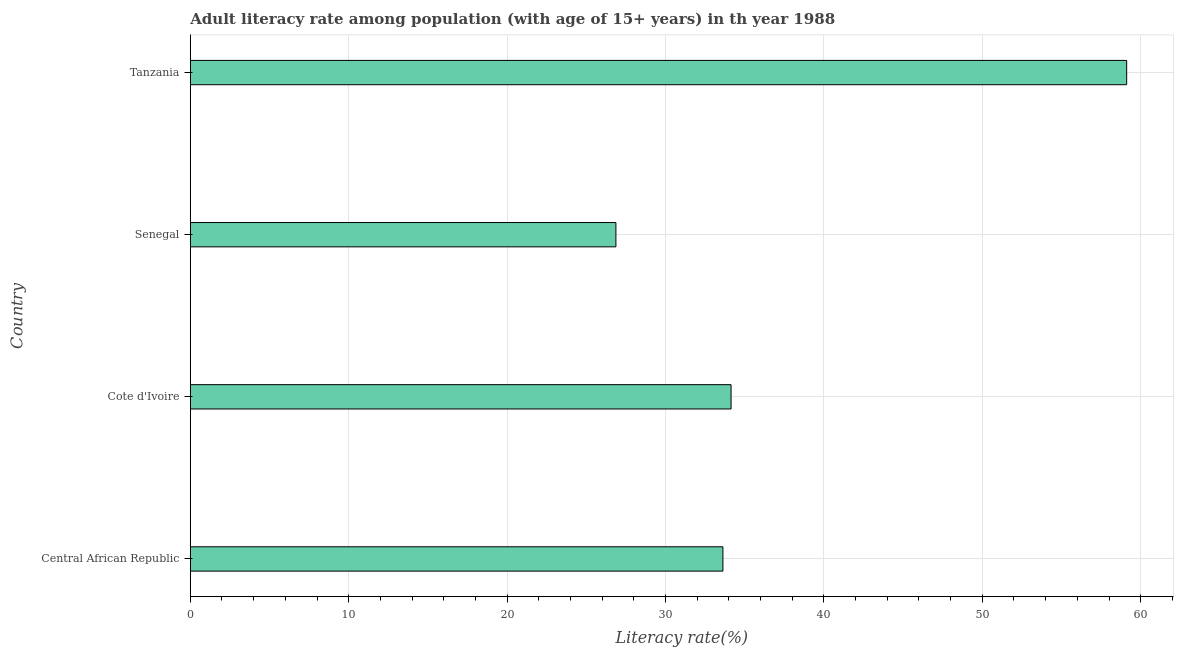Does the graph contain any zero values?
Make the answer very short. No. What is the title of the graph?
Provide a short and direct response. Adult literacy rate among population (with age of 15+ years) in th year 1988. What is the label or title of the X-axis?
Your answer should be very brief. Literacy rate(%). What is the label or title of the Y-axis?
Give a very brief answer. Country. What is the adult literacy rate in Senegal?
Provide a succinct answer. 26.87. Across all countries, what is the maximum adult literacy rate?
Provide a succinct answer. 59.11. Across all countries, what is the minimum adult literacy rate?
Provide a succinct answer. 26.87. In which country was the adult literacy rate maximum?
Your answer should be compact. Tanzania. In which country was the adult literacy rate minimum?
Provide a succinct answer. Senegal. What is the sum of the adult literacy rate?
Offer a very short reply. 153.75. What is the difference between the adult literacy rate in Cote d'Ivoire and Tanzania?
Give a very brief answer. -24.98. What is the average adult literacy rate per country?
Provide a short and direct response. 38.44. What is the median adult literacy rate?
Your response must be concise. 33.88. What is the ratio of the adult literacy rate in Senegal to that in Tanzania?
Offer a very short reply. 0.46. Is the adult literacy rate in Central African Republic less than that in Senegal?
Ensure brevity in your answer.  No. What is the difference between the highest and the second highest adult literacy rate?
Make the answer very short. 24.98. Is the sum of the adult literacy rate in Central African Republic and Senegal greater than the maximum adult literacy rate across all countries?
Provide a short and direct response. Yes. What is the difference between the highest and the lowest adult literacy rate?
Provide a short and direct response. 32.24. Are all the bars in the graph horizontal?
Your answer should be very brief. Yes. What is the difference between two consecutive major ticks on the X-axis?
Ensure brevity in your answer.  10. Are the values on the major ticks of X-axis written in scientific E-notation?
Provide a short and direct response. No. What is the Literacy rate(%) in Central African Republic?
Your response must be concise. 33.62. What is the Literacy rate(%) in Cote d'Ivoire?
Provide a succinct answer. 34.14. What is the Literacy rate(%) of Senegal?
Your answer should be compact. 26.87. What is the Literacy rate(%) in Tanzania?
Provide a succinct answer. 59.11. What is the difference between the Literacy rate(%) in Central African Republic and Cote d'Ivoire?
Provide a short and direct response. -0.51. What is the difference between the Literacy rate(%) in Central African Republic and Senegal?
Offer a terse response. 6.76. What is the difference between the Literacy rate(%) in Central African Republic and Tanzania?
Your response must be concise. -25.49. What is the difference between the Literacy rate(%) in Cote d'Ivoire and Senegal?
Your answer should be compact. 7.27. What is the difference between the Literacy rate(%) in Cote d'Ivoire and Tanzania?
Offer a terse response. -24.97. What is the difference between the Literacy rate(%) in Senegal and Tanzania?
Offer a very short reply. -32.24. What is the ratio of the Literacy rate(%) in Central African Republic to that in Cote d'Ivoire?
Your answer should be very brief. 0.98. What is the ratio of the Literacy rate(%) in Central African Republic to that in Senegal?
Your response must be concise. 1.25. What is the ratio of the Literacy rate(%) in Central African Republic to that in Tanzania?
Your response must be concise. 0.57. What is the ratio of the Literacy rate(%) in Cote d'Ivoire to that in Senegal?
Make the answer very short. 1.27. What is the ratio of the Literacy rate(%) in Cote d'Ivoire to that in Tanzania?
Ensure brevity in your answer.  0.58. What is the ratio of the Literacy rate(%) in Senegal to that in Tanzania?
Your answer should be compact. 0.46. 